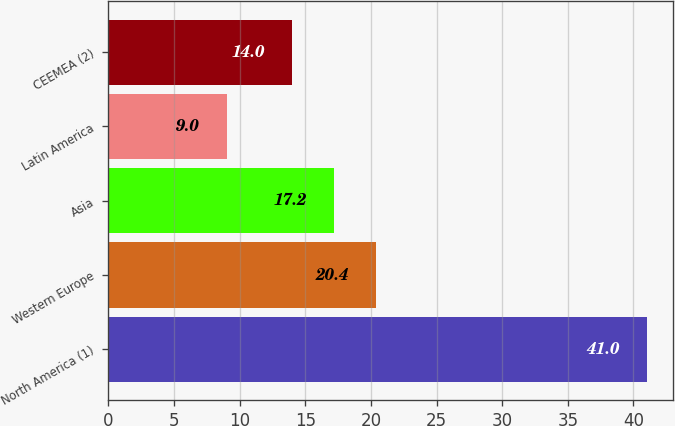Convert chart to OTSL. <chart><loc_0><loc_0><loc_500><loc_500><bar_chart><fcel>North America (1)<fcel>Western Europe<fcel>Asia<fcel>Latin America<fcel>CEEMEA (2)<nl><fcel>41<fcel>20.4<fcel>17.2<fcel>9<fcel>14<nl></chart> 